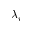Convert formula to latex. <formula><loc_0><loc_0><loc_500><loc_500>\lambda _ { i }</formula> 